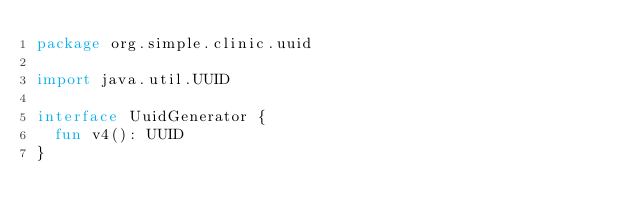Convert code to text. <code><loc_0><loc_0><loc_500><loc_500><_Kotlin_>package org.simple.clinic.uuid

import java.util.UUID

interface UuidGenerator {
  fun v4(): UUID
}
</code> 